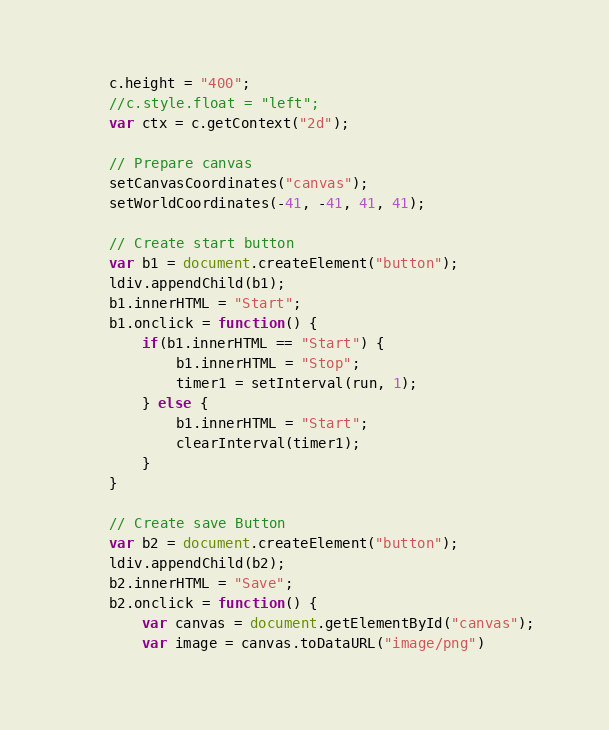Convert code to text. <code><loc_0><loc_0><loc_500><loc_500><_JavaScript_>	c.height = "400";
	//c.style.float = "left";
	var ctx = c.getContext("2d");
	
	// Prepare canvas
	setCanvasCoordinates("canvas");
	setWorldCoordinates(-41, -41, 41, 41);
	
	// Create start button
	var b1 = document.createElement("button");
	ldiv.appendChild(b1);
	b1.innerHTML = "Start";
	b1.onclick = function() {
		if(b1.innerHTML == "Start") {
			b1.innerHTML = "Stop";
			timer1 = setInterval(run, 1);
		} else {
			b1.innerHTML = "Start";
			clearInterval(timer1);
		}
	}
	
	// Create save Button
	var b2 = document.createElement("button");
	ldiv.appendChild(b2);
	b2.innerHTML = "Save";
	b2.onclick = function() {
		var canvas = document.getElementById("canvas");
		var image = canvas.toDataURL("image/png")</code> 